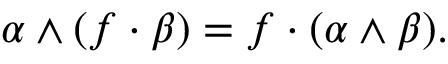<formula> <loc_0><loc_0><loc_500><loc_500>\alpha \wedge ( f \cdot \beta ) = f \cdot ( \alpha \wedge \beta ) .</formula> 